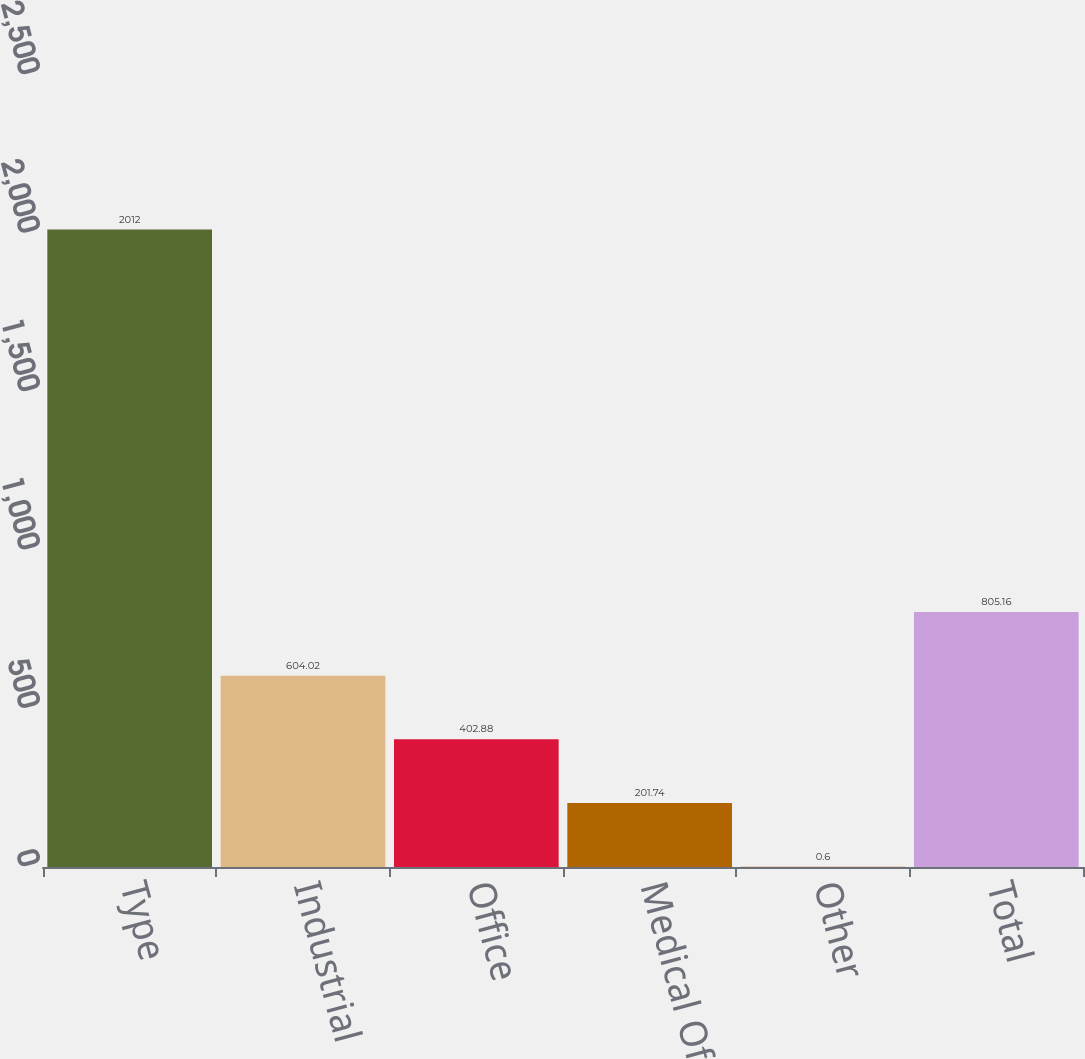Convert chart. <chart><loc_0><loc_0><loc_500><loc_500><bar_chart><fcel>Type<fcel>Industrial<fcel>Office<fcel>Medical Office<fcel>Other<fcel>Total<nl><fcel>2012<fcel>604.02<fcel>402.88<fcel>201.74<fcel>0.6<fcel>805.16<nl></chart> 